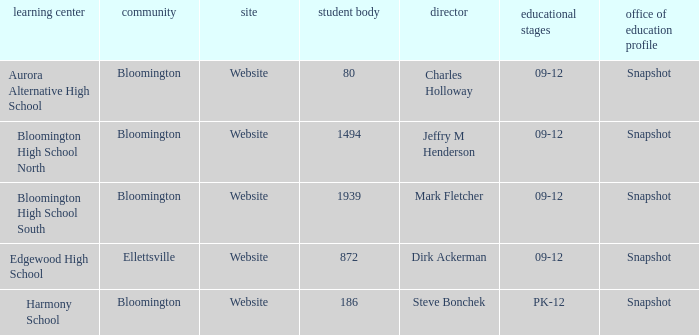Where is Bloomington High School North? Bloomington. 